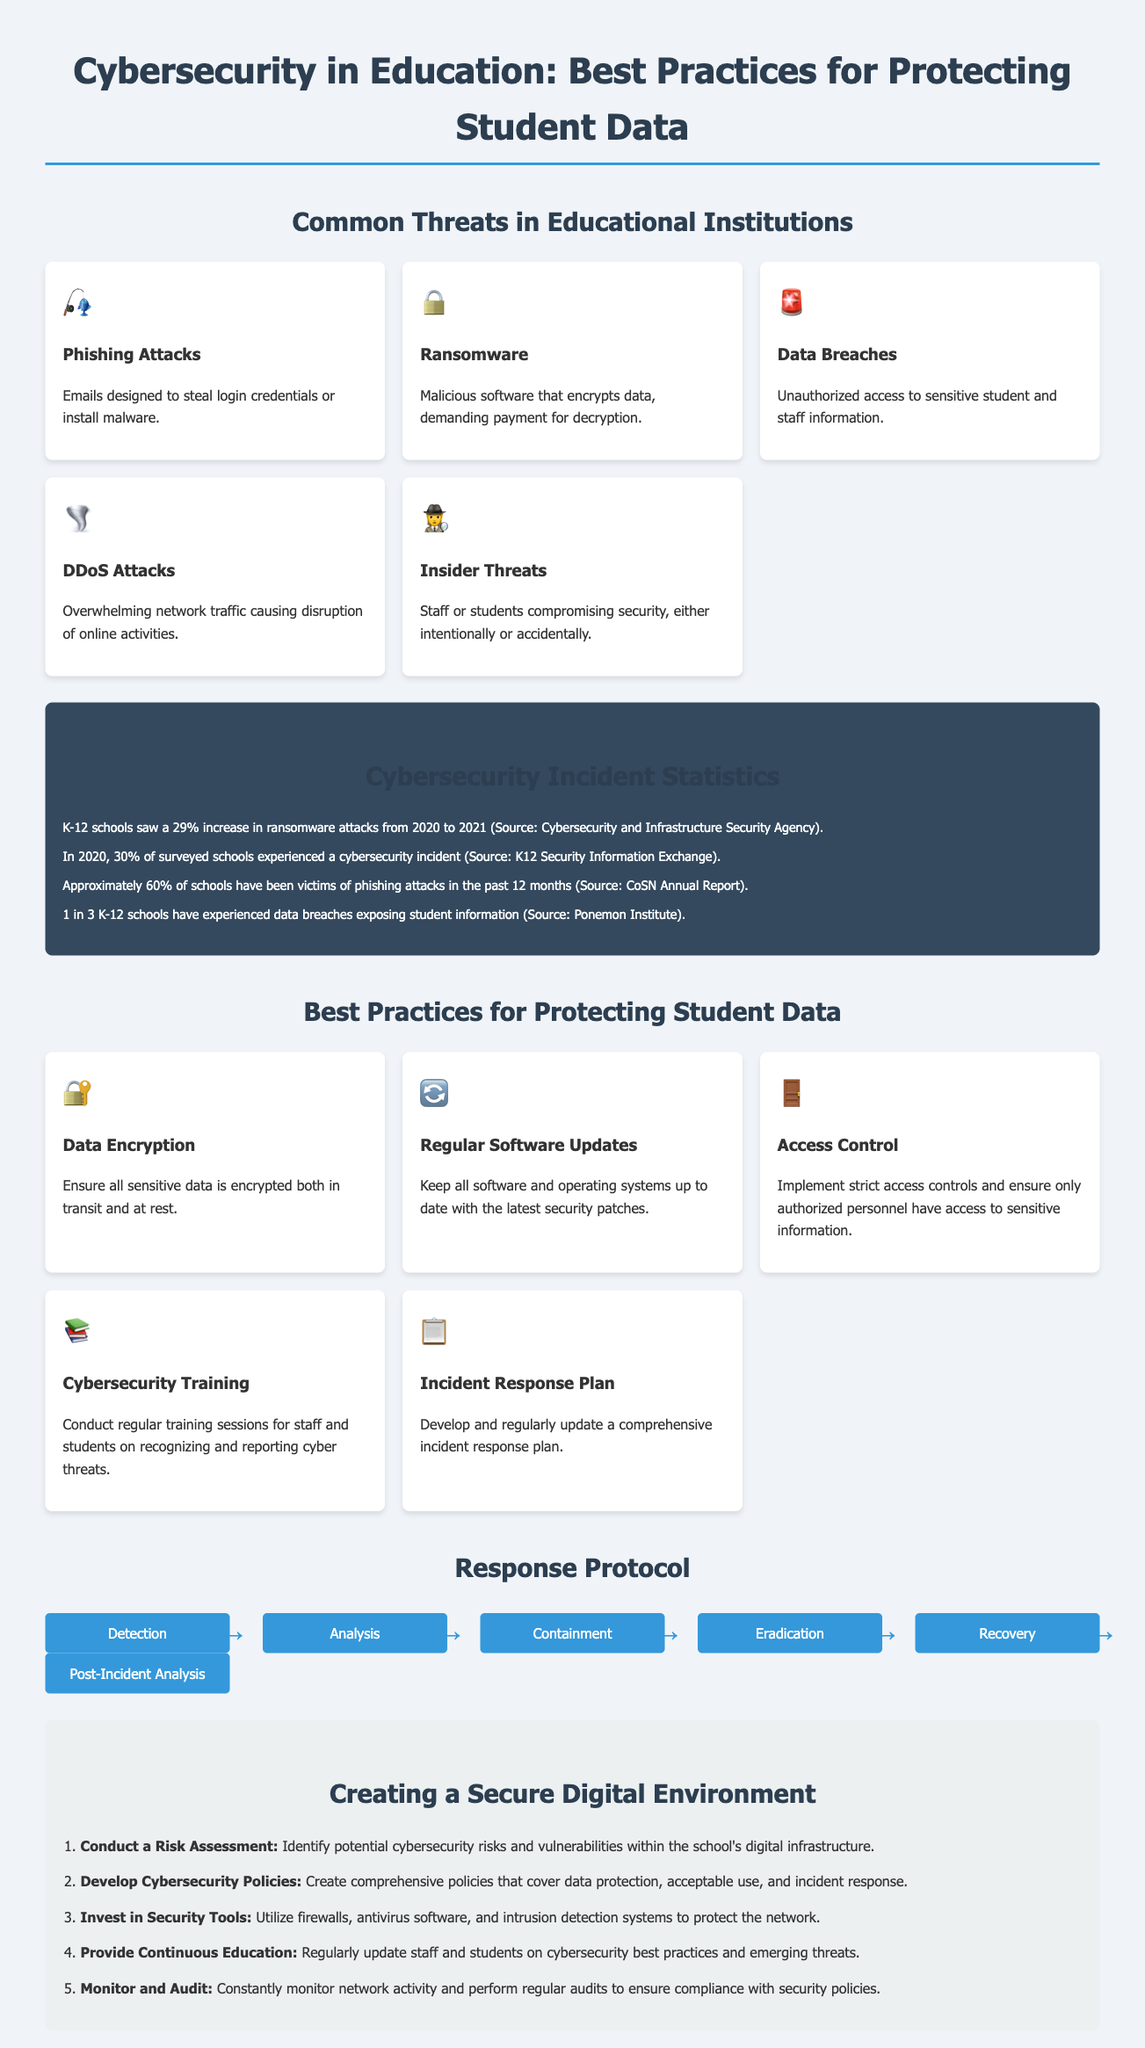What are the five common threats in educational institutions? The document lists phishing attacks, ransomware, data breaches, DDoS attacks, and insider threats as common threats.
Answer: phishing attacks, ransomware, data breaches, DDoS attacks, insider threats What percentage increase in ransomware attacks was observed in K-12 schools from 2020 to 2021? The infographic states there was a 29% increase in ransomware attacks from 2020 to 2021.
Answer: 29% What are three best practices mentioned for protecting student data? The document enumerates data encryption, regular software updates, and access control as best practices.
Answer: data encryption, regular software updates, access control How many steps are in the response protocol flowchart? The flowchart contains six distinct steps in the response protocol.
Answer: six What type of educational sessions are advised to conduct for staff and students? The best practices recommendation includes conducting regular training sessions related to cybersecurity.
Answer: cybersecurity training What is one of the steps for creating a secure digital environment? The infographic mentions conducting a risk assessment as an initial step in creating a secure environment.
Answer: Conduct a Risk Assessment Which body reported on the 30% of surveyed schools experiencing a cybersecurity incident? The source of the statistic about 30% of schools experiencing a cybersecurity incident is the K12 Security Information Exchange.
Answer: K12 Security Information Exchange What is recommended to invest in for enhanced security? The document suggests investing in firewalls, antivirus software, and intrusion detection systems as security measures.
Answer: security tools 